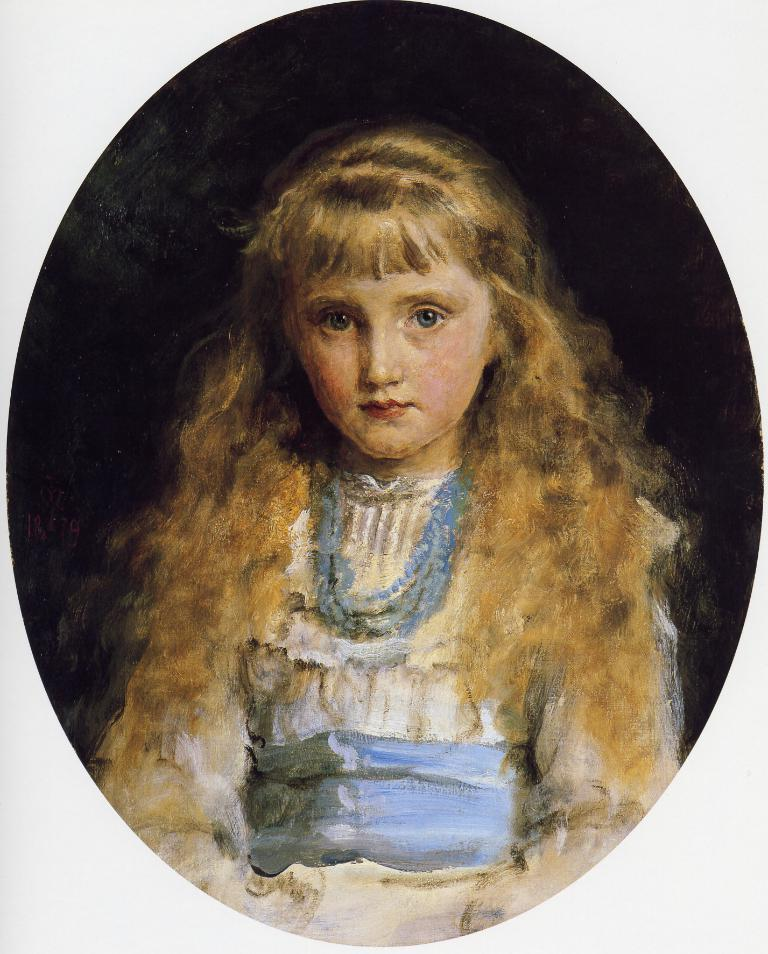What type of artwork is shown in the image? The image is a painting. Who or what is the main subject of the painting? The painting depicts a girl. Is the painting displayed in any specific way? The painting is in a frame. What type of fruit is the girl holding in the painting? There is no fruit present in the painting; it depicts a girl without any objects. 